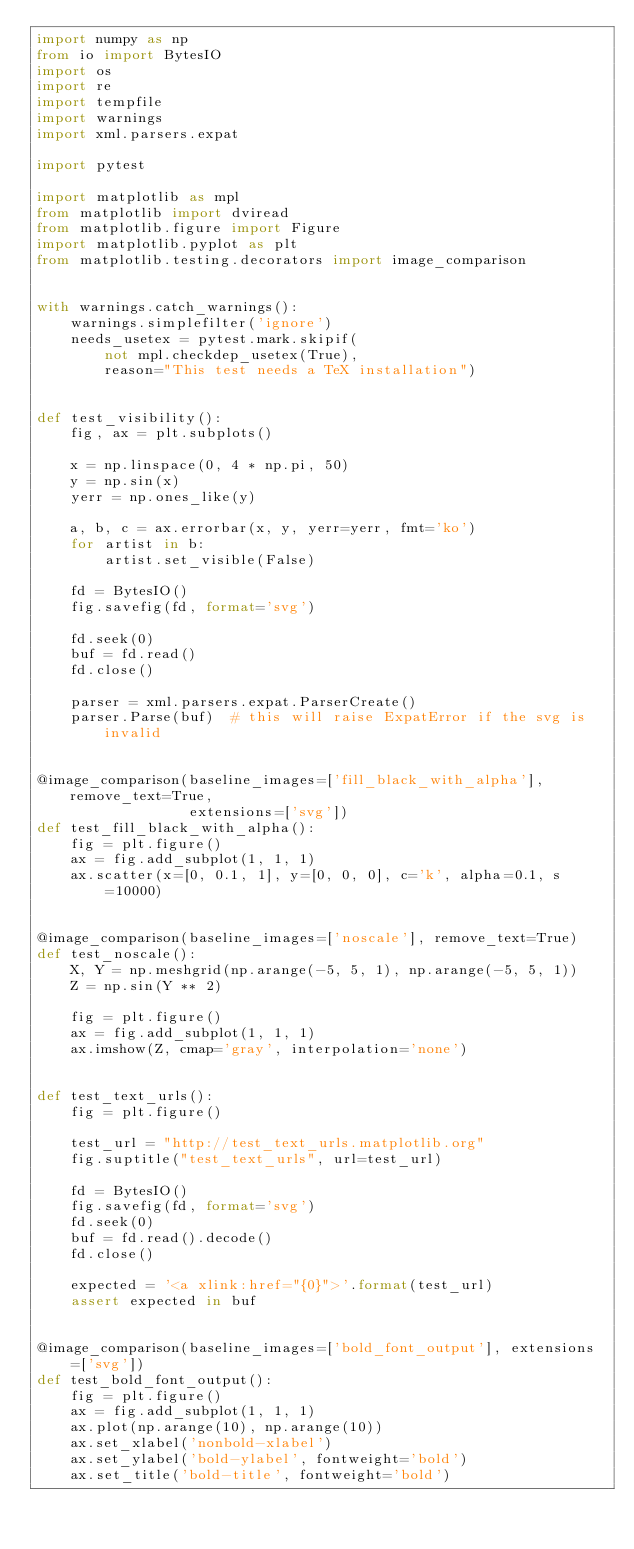Convert code to text. <code><loc_0><loc_0><loc_500><loc_500><_Python_>import numpy as np
from io import BytesIO
import os
import re
import tempfile
import warnings
import xml.parsers.expat

import pytest

import matplotlib as mpl
from matplotlib import dviread
from matplotlib.figure import Figure
import matplotlib.pyplot as plt
from matplotlib.testing.decorators import image_comparison


with warnings.catch_warnings():
    warnings.simplefilter('ignore')
    needs_usetex = pytest.mark.skipif(
        not mpl.checkdep_usetex(True),
        reason="This test needs a TeX installation")


def test_visibility():
    fig, ax = plt.subplots()

    x = np.linspace(0, 4 * np.pi, 50)
    y = np.sin(x)
    yerr = np.ones_like(y)

    a, b, c = ax.errorbar(x, y, yerr=yerr, fmt='ko')
    for artist in b:
        artist.set_visible(False)

    fd = BytesIO()
    fig.savefig(fd, format='svg')

    fd.seek(0)
    buf = fd.read()
    fd.close()

    parser = xml.parsers.expat.ParserCreate()
    parser.Parse(buf)  # this will raise ExpatError if the svg is invalid


@image_comparison(baseline_images=['fill_black_with_alpha'], remove_text=True,
                  extensions=['svg'])
def test_fill_black_with_alpha():
    fig = plt.figure()
    ax = fig.add_subplot(1, 1, 1)
    ax.scatter(x=[0, 0.1, 1], y=[0, 0, 0], c='k', alpha=0.1, s=10000)


@image_comparison(baseline_images=['noscale'], remove_text=True)
def test_noscale():
    X, Y = np.meshgrid(np.arange(-5, 5, 1), np.arange(-5, 5, 1))
    Z = np.sin(Y ** 2)

    fig = plt.figure()
    ax = fig.add_subplot(1, 1, 1)
    ax.imshow(Z, cmap='gray', interpolation='none')


def test_text_urls():
    fig = plt.figure()

    test_url = "http://test_text_urls.matplotlib.org"
    fig.suptitle("test_text_urls", url=test_url)

    fd = BytesIO()
    fig.savefig(fd, format='svg')
    fd.seek(0)
    buf = fd.read().decode()
    fd.close()

    expected = '<a xlink:href="{0}">'.format(test_url)
    assert expected in buf


@image_comparison(baseline_images=['bold_font_output'], extensions=['svg'])
def test_bold_font_output():
    fig = plt.figure()
    ax = fig.add_subplot(1, 1, 1)
    ax.plot(np.arange(10), np.arange(10))
    ax.set_xlabel('nonbold-xlabel')
    ax.set_ylabel('bold-ylabel', fontweight='bold')
    ax.set_title('bold-title', fontweight='bold')

</code> 